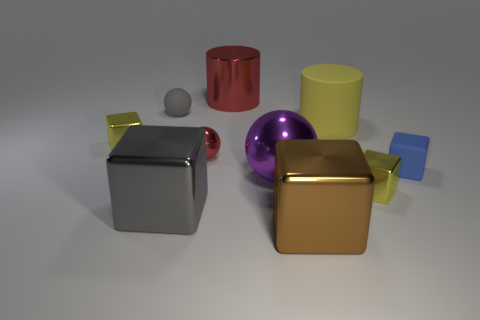Is there anything else that has the same shape as the yellow rubber object?
Your answer should be very brief. Yes. There is a rubber thing in front of the small block behind the blue rubber object; what is its color?
Your answer should be compact. Blue. What number of small metallic balls are there?
Provide a succinct answer. 1. What number of matte objects are big yellow objects or balls?
Offer a very short reply. 2. How many large metal things have the same color as the large metallic cylinder?
Provide a short and direct response. 0. What is the material of the tiny sphere that is to the right of the tiny gray rubber object that is in front of the big red object?
Your response must be concise. Metal. What size is the blue matte cube?
Offer a terse response. Small. What number of cubes have the same size as the gray ball?
Your answer should be very brief. 3. How many brown metallic things are the same shape as the large red shiny object?
Your answer should be very brief. 0. Are there an equal number of big yellow cylinders behind the yellow matte object and rubber things?
Ensure brevity in your answer.  No. 